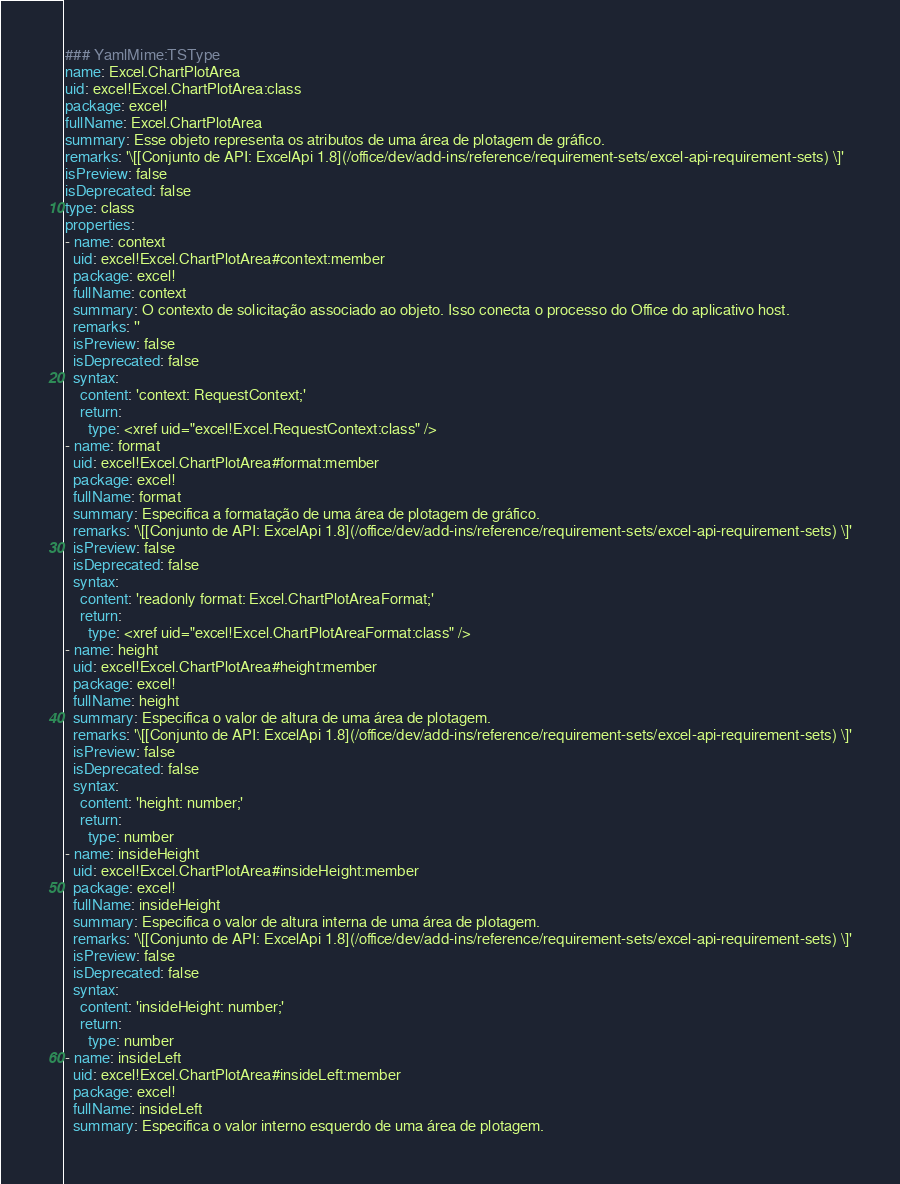Convert code to text. <code><loc_0><loc_0><loc_500><loc_500><_YAML_>### YamlMime:TSType
name: Excel.ChartPlotArea
uid: excel!Excel.ChartPlotArea:class
package: excel!
fullName: Excel.ChartPlotArea
summary: Esse objeto representa os atributos de uma área de plotagem de gráfico.
remarks: '\[[Conjunto de API: ExcelApi 1.8](/office/dev/add-ins/reference/requirement-sets/excel-api-requirement-sets) \]'
isPreview: false
isDeprecated: false
type: class
properties:
- name: context
  uid: excel!Excel.ChartPlotArea#context:member
  package: excel!
  fullName: context
  summary: O contexto de solicitação associado ao objeto. Isso conecta o processo do Office do aplicativo host.
  remarks: ''
  isPreview: false
  isDeprecated: false
  syntax:
    content: 'context: RequestContext;'
    return:
      type: <xref uid="excel!Excel.RequestContext:class" />
- name: format
  uid: excel!Excel.ChartPlotArea#format:member
  package: excel!
  fullName: format
  summary: Especifica a formatação de uma área de plotagem de gráfico.
  remarks: '\[[Conjunto de API: ExcelApi 1.8](/office/dev/add-ins/reference/requirement-sets/excel-api-requirement-sets) \]'
  isPreview: false
  isDeprecated: false
  syntax:
    content: 'readonly format: Excel.ChartPlotAreaFormat;'
    return:
      type: <xref uid="excel!Excel.ChartPlotAreaFormat:class" />
- name: height
  uid: excel!Excel.ChartPlotArea#height:member
  package: excel!
  fullName: height
  summary: Especifica o valor de altura de uma área de plotagem.
  remarks: '\[[Conjunto de API: ExcelApi 1.8](/office/dev/add-ins/reference/requirement-sets/excel-api-requirement-sets) \]'
  isPreview: false
  isDeprecated: false
  syntax:
    content: 'height: number;'
    return:
      type: number
- name: insideHeight
  uid: excel!Excel.ChartPlotArea#insideHeight:member
  package: excel!
  fullName: insideHeight
  summary: Especifica o valor de altura interna de uma área de plotagem.
  remarks: '\[[Conjunto de API: ExcelApi 1.8](/office/dev/add-ins/reference/requirement-sets/excel-api-requirement-sets) \]'
  isPreview: false
  isDeprecated: false
  syntax:
    content: 'insideHeight: number;'
    return:
      type: number
- name: insideLeft
  uid: excel!Excel.ChartPlotArea#insideLeft:member
  package: excel!
  fullName: insideLeft
  summary: Especifica o valor interno esquerdo de uma área de plotagem.</code> 